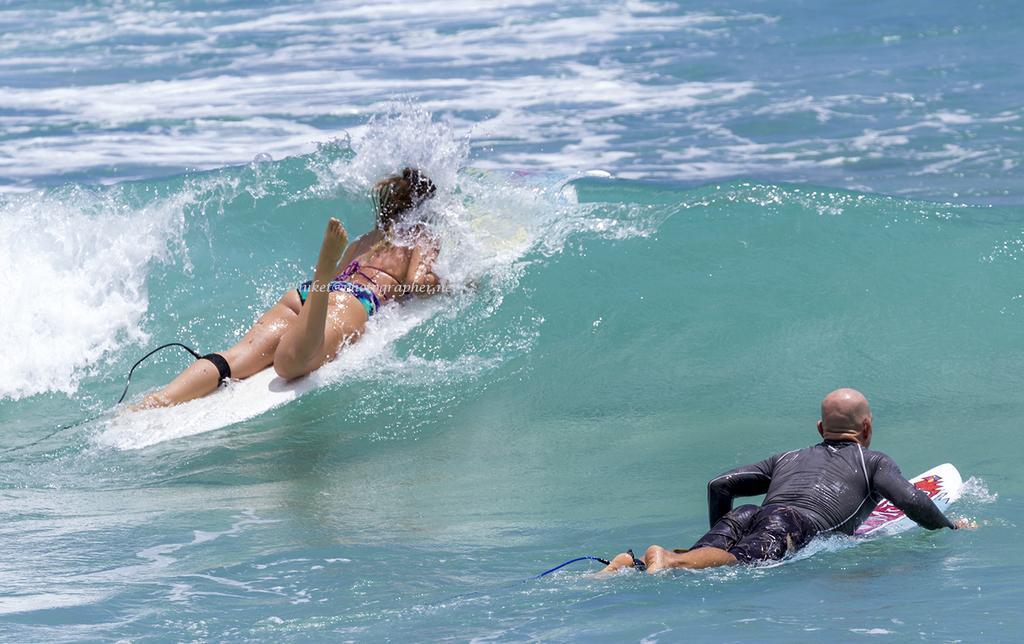Could you give a brief overview of what you see in this image? In this image I see a a woman and a man and both of them are lying on the surf board and they are on the water. 